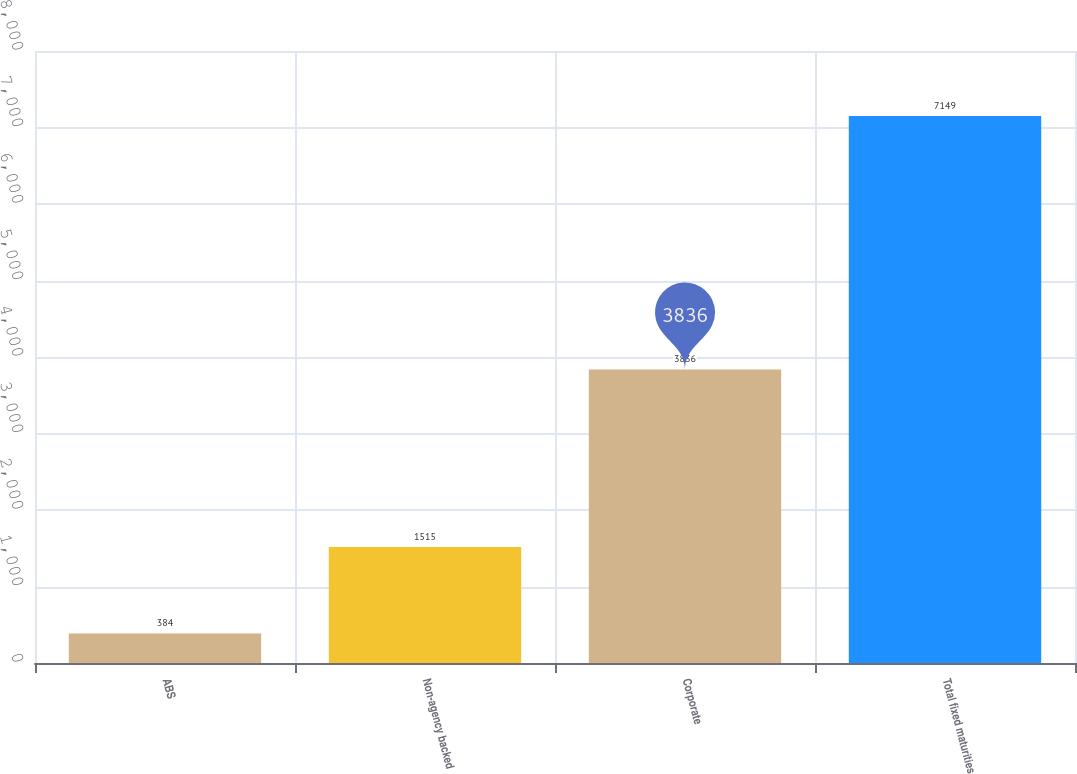Convert chart to OTSL. <chart><loc_0><loc_0><loc_500><loc_500><bar_chart><fcel>ABS<fcel>Non-agency backed<fcel>Corporate<fcel>Total fixed maturities<nl><fcel>384<fcel>1515<fcel>3836<fcel>7149<nl></chart> 